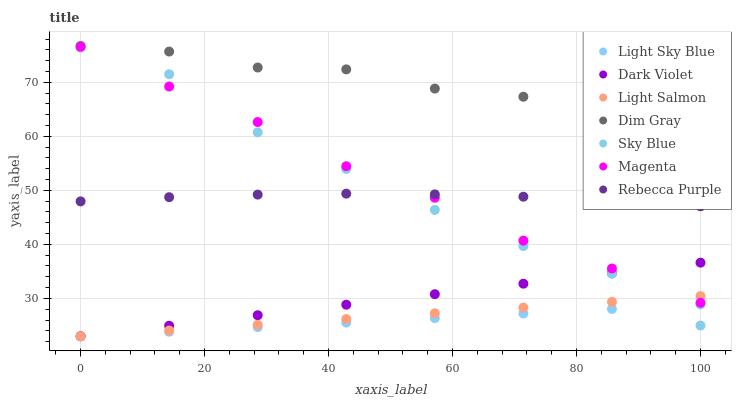Does Light Sky Blue have the minimum area under the curve?
Answer yes or no. Yes. Does Dim Gray have the maximum area under the curve?
Answer yes or no. Yes. Does Dark Violet have the minimum area under the curve?
Answer yes or no. No. Does Dark Violet have the maximum area under the curve?
Answer yes or no. No. Is Light Salmon the smoothest?
Answer yes or no. Yes. Is Sky Blue the roughest?
Answer yes or no. Yes. Is Dim Gray the smoothest?
Answer yes or no. No. Is Dim Gray the roughest?
Answer yes or no. No. Does Light Salmon have the lowest value?
Answer yes or no. Yes. Does Dim Gray have the lowest value?
Answer yes or no. No. Does Dim Gray have the highest value?
Answer yes or no. Yes. Does Dark Violet have the highest value?
Answer yes or no. No. Is Dark Violet less than Dim Gray?
Answer yes or no. Yes. Is Rebecca Purple greater than Dark Violet?
Answer yes or no. Yes. Does Magenta intersect Light Salmon?
Answer yes or no. Yes. Is Magenta less than Light Salmon?
Answer yes or no. No. Is Magenta greater than Light Salmon?
Answer yes or no. No. Does Dark Violet intersect Dim Gray?
Answer yes or no. No. 